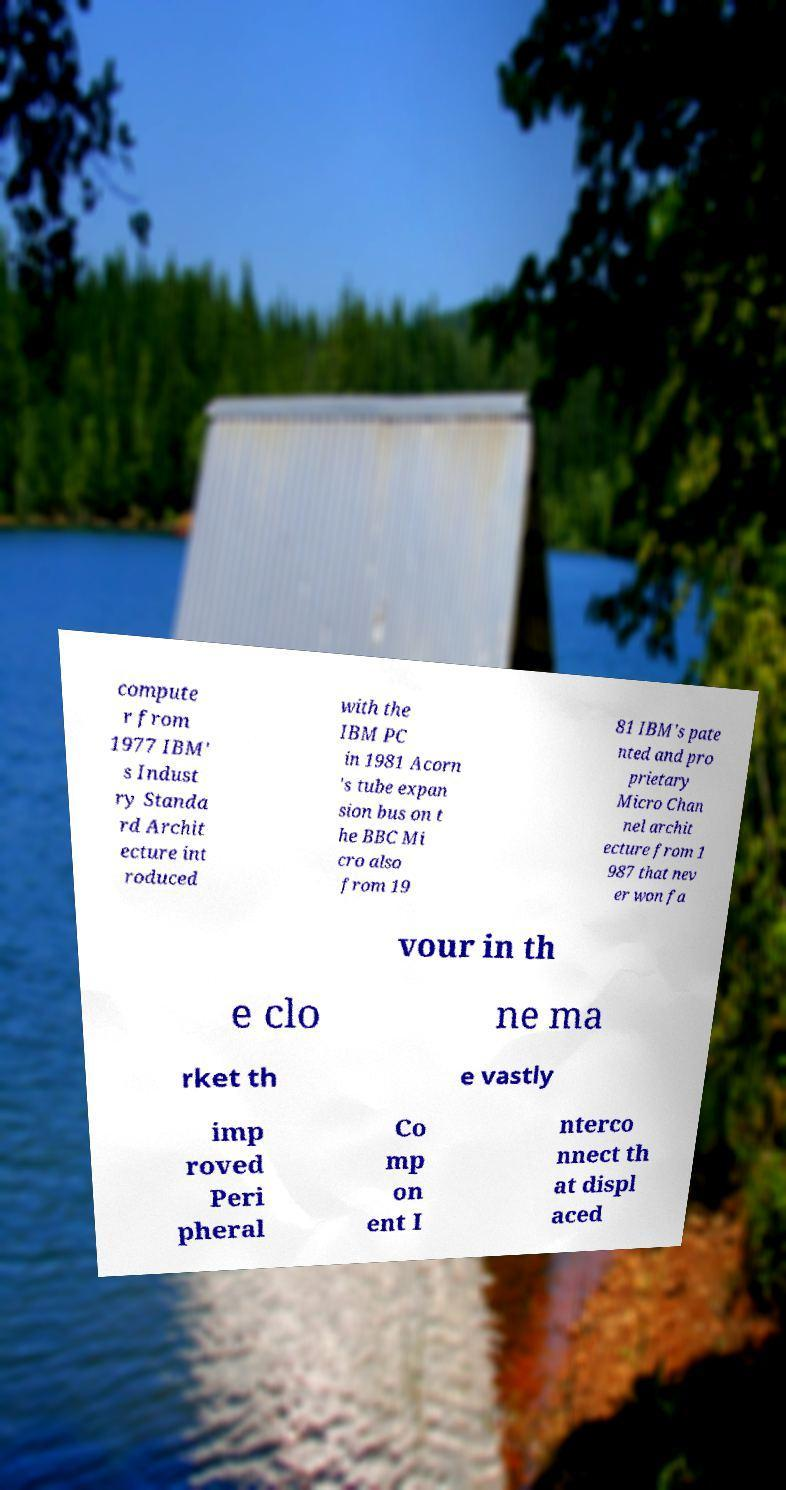For documentation purposes, I need the text within this image transcribed. Could you provide that? compute r from 1977 IBM' s Indust ry Standa rd Archit ecture int roduced with the IBM PC in 1981 Acorn 's tube expan sion bus on t he BBC Mi cro also from 19 81 IBM's pate nted and pro prietary Micro Chan nel archit ecture from 1 987 that nev er won fa vour in th e clo ne ma rket th e vastly imp roved Peri pheral Co mp on ent I nterco nnect th at displ aced 